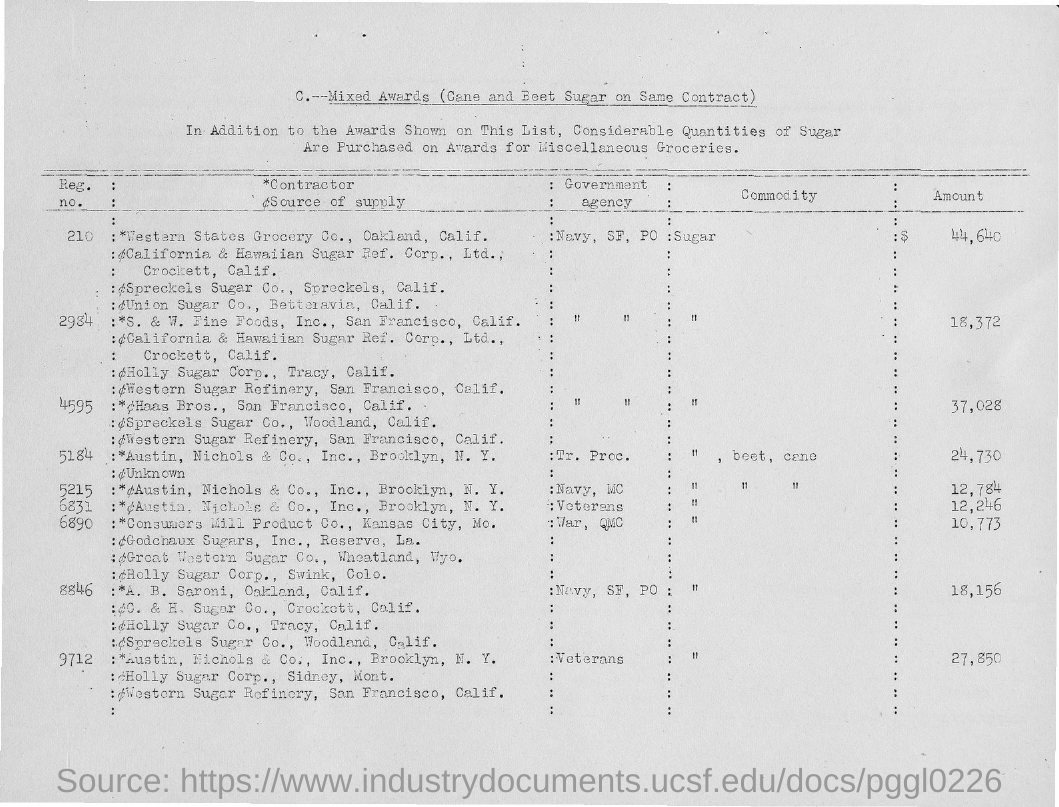Indicate a few pertinent items in this graphic. The amount for sugar with Registration Number 210 is $44,640. The amount for sugar with Registration Number 4595 is 37,028. 